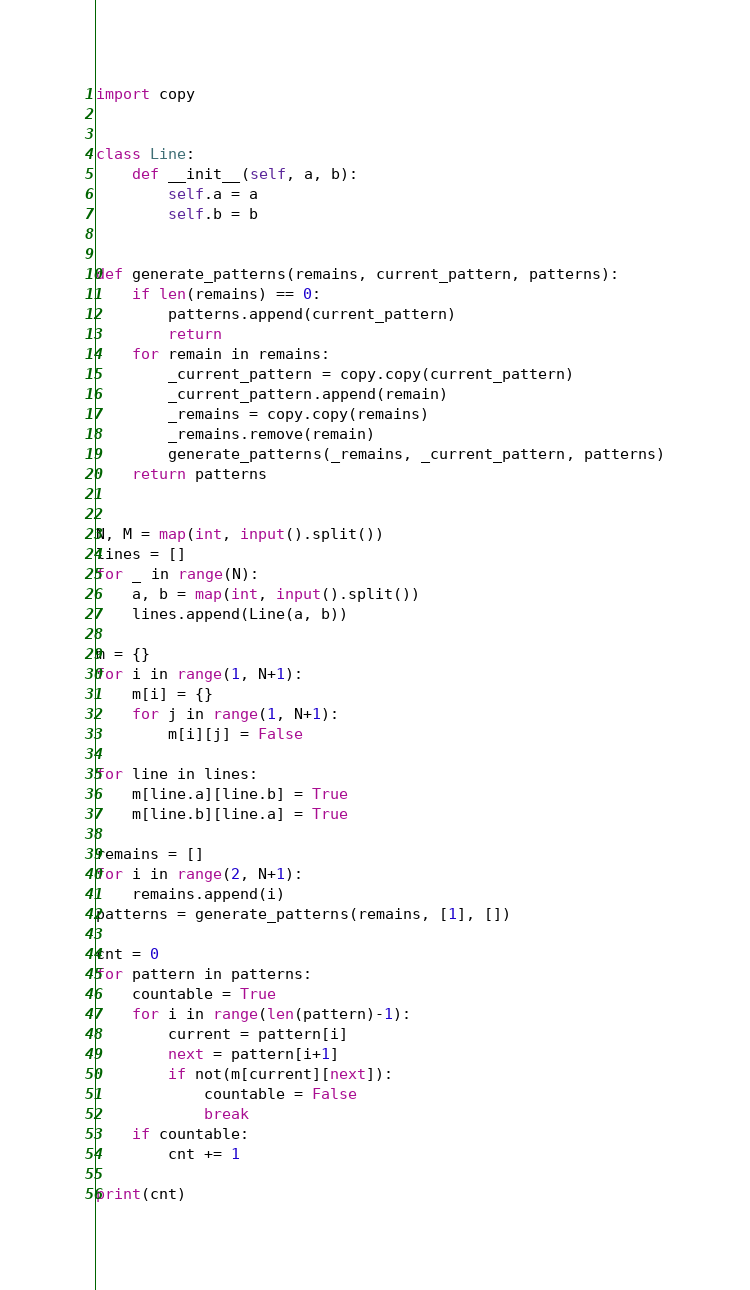Convert code to text. <code><loc_0><loc_0><loc_500><loc_500><_Python_>import copy


class Line:
    def __init__(self, a, b):
        self.a = a
        self.b = b


def generate_patterns(remains, current_pattern, patterns):
    if len(remains) == 0:
        patterns.append(current_pattern)
        return
    for remain in remains:
        _current_pattern = copy.copy(current_pattern)
        _current_pattern.append(remain)
        _remains = copy.copy(remains)
        _remains.remove(remain)
        generate_patterns(_remains, _current_pattern, patterns)
    return patterns


N, M = map(int, input().split())
lines = []
for _ in range(N):
    a, b = map(int, input().split())
    lines.append(Line(a, b))

m = {}
for i in range(1, N+1):
    m[i] = {}
    for j in range(1, N+1):
        m[i][j] = False

for line in lines:
    m[line.a][line.b] = True
    m[line.b][line.a] = True

remains = []
for i in range(2, N+1):
    remains.append(i)
patterns = generate_patterns(remains, [1], [])

cnt = 0
for pattern in patterns:
    countable = True
    for i in range(len(pattern)-1):
        current = pattern[i]
        next = pattern[i+1]
        if not(m[current][next]):
            countable = False
            break
    if countable:
        cnt += 1

print(cnt)
</code> 